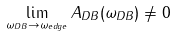Convert formula to latex. <formula><loc_0><loc_0><loc_500><loc_500>\lim _ { \omega _ { D B } \to \omega _ { e d g e } } A _ { D B } ( \omega _ { D B } ) \neq 0</formula> 